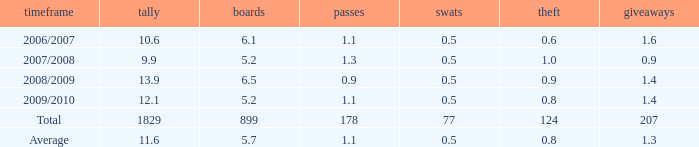How many blocks are there when the rebounds are fewer than 5.2? 0.0. 